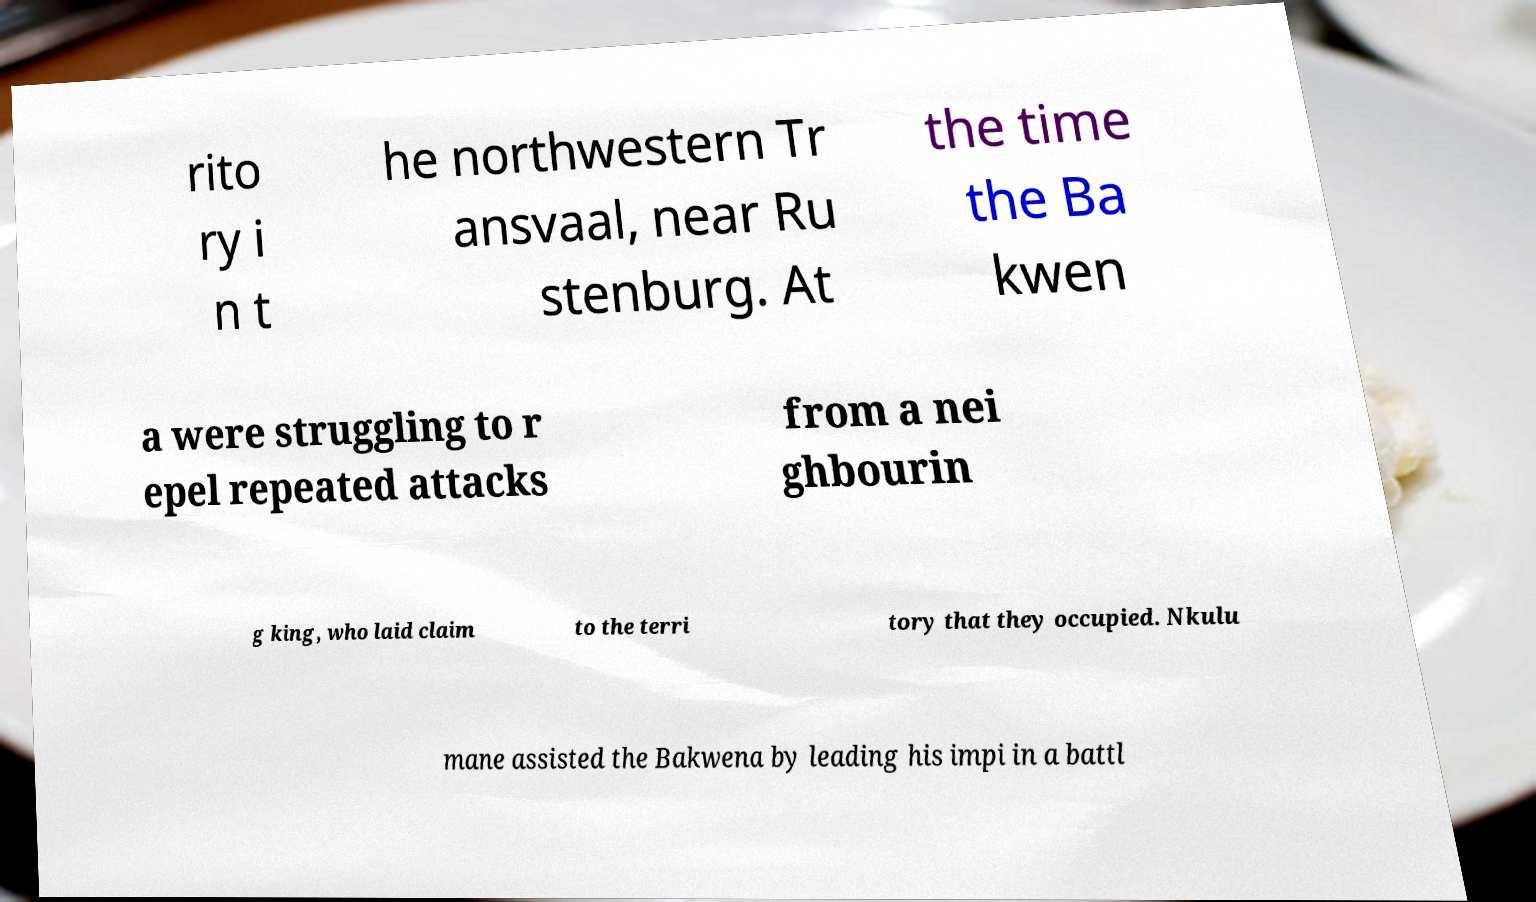There's text embedded in this image that I need extracted. Can you transcribe it verbatim? rito ry i n t he northwestern Tr ansvaal, near Ru stenburg. At the time the Ba kwen a were struggling to r epel repeated attacks from a nei ghbourin g king, who laid claim to the terri tory that they occupied. Nkulu mane assisted the Bakwena by leading his impi in a battl 